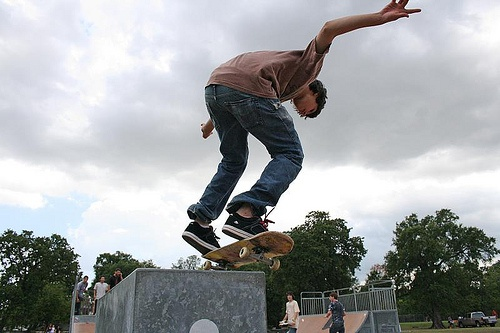Describe the objects in this image and their specific colors. I can see people in lavender, black, gray, and maroon tones, skateboard in lavender, maroon, black, and gray tones, people in lavender, black, and gray tones, truck in lavender, black, gray, and darkgray tones, and people in lavender, darkgray, black, and gray tones in this image. 